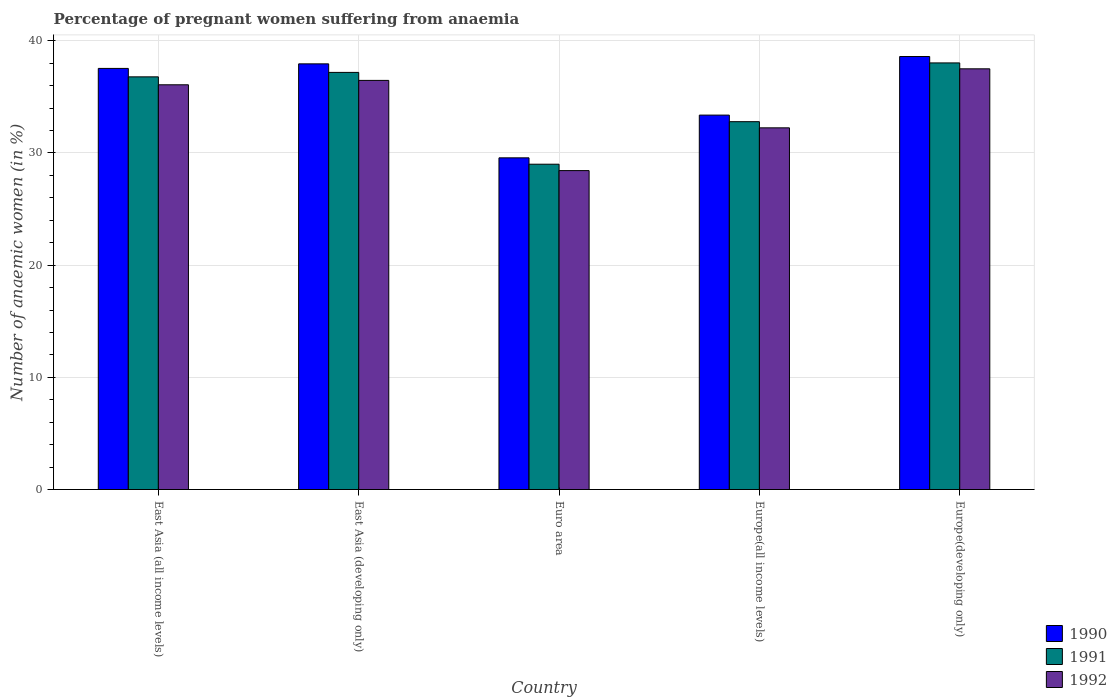Are the number of bars per tick equal to the number of legend labels?
Give a very brief answer. Yes. Are the number of bars on each tick of the X-axis equal?
Offer a terse response. Yes. What is the label of the 3rd group of bars from the left?
Keep it short and to the point. Euro area. What is the number of anaemic women in 1991 in Europe(developing only)?
Keep it short and to the point. 38.02. Across all countries, what is the maximum number of anaemic women in 1992?
Offer a very short reply. 37.5. Across all countries, what is the minimum number of anaemic women in 1992?
Give a very brief answer. 28.43. In which country was the number of anaemic women in 1992 maximum?
Your response must be concise. Europe(developing only). In which country was the number of anaemic women in 1992 minimum?
Your answer should be compact. Euro area. What is the total number of anaemic women in 1992 in the graph?
Provide a succinct answer. 170.7. What is the difference between the number of anaemic women in 1991 in East Asia (all income levels) and that in Europe(developing only)?
Your response must be concise. -1.24. What is the difference between the number of anaemic women in 1991 in Europe(developing only) and the number of anaemic women in 1992 in East Asia (developing only)?
Give a very brief answer. 1.56. What is the average number of anaemic women in 1991 per country?
Give a very brief answer. 34.75. What is the difference between the number of anaemic women of/in 1991 and number of anaemic women of/in 1990 in Europe(all income levels)?
Your response must be concise. -0.59. In how many countries, is the number of anaemic women in 1990 greater than 32 %?
Your response must be concise. 4. What is the ratio of the number of anaemic women in 1990 in Euro area to that in Europe(all income levels)?
Your answer should be compact. 0.89. What is the difference between the highest and the second highest number of anaemic women in 1990?
Provide a short and direct response. -0.41. What is the difference between the highest and the lowest number of anaemic women in 1992?
Your response must be concise. 9.07. What does the 1st bar from the left in Europe(all income levels) represents?
Keep it short and to the point. 1990. What does the 3rd bar from the right in East Asia (all income levels) represents?
Give a very brief answer. 1990. How many bars are there?
Provide a succinct answer. 15. Are all the bars in the graph horizontal?
Make the answer very short. No. What is the difference between two consecutive major ticks on the Y-axis?
Your answer should be very brief. 10. Are the values on the major ticks of Y-axis written in scientific E-notation?
Your response must be concise. No. Does the graph contain any zero values?
Your answer should be compact. No. Where does the legend appear in the graph?
Your answer should be compact. Bottom right. How many legend labels are there?
Give a very brief answer. 3. What is the title of the graph?
Make the answer very short. Percentage of pregnant women suffering from anaemia. Does "2014" appear as one of the legend labels in the graph?
Your answer should be very brief. No. What is the label or title of the Y-axis?
Your answer should be very brief. Number of anaemic women (in %). What is the Number of anaemic women (in %) in 1990 in East Asia (all income levels)?
Give a very brief answer. 37.53. What is the Number of anaemic women (in %) of 1991 in East Asia (all income levels)?
Provide a short and direct response. 36.78. What is the Number of anaemic women (in %) of 1992 in East Asia (all income levels)?
Keep it short and to the point. 36.07. What is the Number of anaemic women (in %) in 1990 in East Asia (developing only)?
Ensure brevity in your answer.  37.94. What is the Number of anaemic women (in %) in 1991 in East Asia (developing only)?
Keep it short and to the point. 37.18. What is the Number of anaemic women (in %) in 1992 in East Asia (developing only)?
Provide a succinct answer. 36.47. What is the Number of anaemic women (in %) in 1990 in Euro area?
Give a very brief answer. 29.56. What is the Number of anaemic women (in %) in 1991 in Euro area?
Provide a short and direct response. 29. What is the Number of anaemic women (in %) in 1992 in Euro area?
Make the answer very short. 28.43. What is the Number of anaemic women (in %) of 1990 in Europe(all income levels)?
Provide a succinct answer. 33.37. What is the Number of anaemic women (in %) in 1991 in Europe(all income levels)?
Your response must be concise. 32.79. What is the Number of anaemic women (in %) of 1992 in Europe(all income levels)?
Your answer should be very brief. 32.24. What is the Number of anaemic women (in %) in 1990 in Europe(developing only)?
Give a very brief answer. 38.59. What is the Number of anaemic women (in %) in 1991 in Europe(developing only)?
Provide a short and direct response. 38.02. What is the Number of anaemic women (in %) in 1992 in Europe(developing only)?
Offer a terse response. 37.5. Across all countries, what is the maximum Number of anaemic women (in %) of 1990?
Your answer should be very brief. 38.59. Across all countries, what is the maximum Number of anaemic women (in %) of 1991?
Provide a short and direct response. 38.02. Across all countries, what is the maximum Number of anaemic women (in %) of 1992?
Provide a succinct answer. 37.5. Across all countries, what is the minimum Number of anaemic women (in %) of 1990?
Provide a short and direct response. 29.56. Across all countries, what is the minimum Number of anaemic women (in %) in 1991?
Ensure brevity in your answer.  29. Across all countries, what is the minimum Number of anaemic women (in %) in 1992?
Make the answer very short. 28.43. What is the total Number of anaemic women (in %) in 1990 in the graph?
Ensure brevity in your answer.  177. What is the total Number of anaemic women (in %) of 1991 in the graph?
Provide a succinct answer. 173.77. What is the total Number of anaemic women (in %) in 1992 in the graph?
Offer a terse response. 170.7. What is the difference between the Number of anaemic women (in %) of 1990 in East Asia (all income levels) and that in East Asia (developing only)?
Ensure brevity in your answer.  -0.41. What is the difference between the Number of anaemic women (in %) of 1991 in East Asia (all income levels) and that in East Asia (developing only)?
Your answer should be compact. -0.4. What is the difference between the Number of anaemic women (in %) of 1992 in East Asia (all income levels) and that in East Asia (developing only)?
Offer a very short reply. -0.39. What is the difference between the Number of anaemic women (in %) in 1990 in East Asia (all income levels) and that in Euro area?
Provide a short and direct response. 7.97. What is the difference between the Number of anaemic women (in %) of 1991 in East Asia (all income levels) and that in Euro area?
Provide a short and direct response. 7.79. What is the difference between the Number of anaemic women (in %) in 1992 in East Asia (all income levels) and that in Euro area?
Offer a terse response. 7.65. What is the difference between the Number of anaemic women (in %) of 1990 in East Asia (all income levels) and that in Europe(all income levels)?
Make the answer very short. 4.16. What is the difference between the Number of anaemic women (in %) of 1991 in East Asia (all income levels) and that in Europe(all income levels)?
Your answer should be very brief. 4. What is the difference between the Number of anaemic women (in %) of 1992 in East Asia (all income levels) and that in Europe(all income levels)?
Your answer should be very brief. 3.84. What is the difference between the Number of anaemic women (in %) in 1990 in East Asia (all income levels) and that in Europe(developing only)?
Your answer should be very brief. -1.06. What is the difference between the Number of anaemic women (in %) in 1991 in East Asia (all income levels) and that in Europe(developing only)?
Ensure brevity in your answer.  -1.24. What is the difference between the Number of anaemic women (in %) in 1992 in East Asia (all income levels) and that in Europe(developing only)?
Your answer should be compact. -1.42. What is the difference between the Number of anaemic women (in %) in 1990 in East Asia (developing only) and that in Euro area?
Your answer should be compact. 8.38. What is the difference between the Number of anaemic women (in %) of 1991 in East Asia (developing only) and that in Euro area?
Offer a terse response. 8.18. What is the difference between the Number of anaemic women (in %) in 1992 in East Asia (developing only) and that in Euro area?
Offer a very short reply. 8.04. What is the difference between the Number of anaemic women (in %) in 1990 in East Asia (developing only) and that in Europe(all income levels)?
Provide a succinct answer. 4.57. What is the difference between the Number of anaemic women (in %) of 1991 in East Asia (developing only) and that in Europe(all income levels)?
Your response must be concise. 4.39. What is the difference between the Number of anaemic women (in %) in 1992 in East Asia (developing only) and that in Europe(all income levels)?
Offer a very short reply. 4.23. What is the difference between the Number of anaemic women (in %) in 1990 in East Asia (developing only) and that in Europe(developing only)?
Your answer should be compact. -0.65. What is the difference between the Number of anaemic women (in %) in 1991 in East Asia (developing only) and that in Europe(developing only)?
Make the answer very short. -0.85. What is the difference between the Number of anaemic women (in %) in 1992 in East Asia (developing only) and that in Europe(developing only)?
Your answer should be very brief. -1.03. What is the difference between the Number of anaemic women (in %) in 1990 in Euro area and that in Europe(all income levels)?
Make the answer very short. -3.81. What is the difference between the Number of anaemic women (in %) of 1991 in Euro area and that in Europe(all income levels)?
Provide a succinct answer. -3.79. What is the difference between the Number of anaemic women (in %) in 1992 in Euro area and that in Europe(all income levels)?
Keep it short and to the point. -3.81. What is the difference between the Number of anaemic women (in %) in 1990 in Euro area and that in Europe(developing only)?
Your answer should be compact. -9.03. What is the difference between the Number of anaemic women (in %) of 1991 in Euro area and that in Europe(developing only)?
Keep it short and to the point. -9.03. What is the difference between the Number of anaemic women (in %) in 1992 in Euro area and that in Europe(developing only)?
Provide a succinct answer. -9.07. What is the difference between the Number of anaemic women (in %) of 1990 in Europe(all income levels) and that in Europe(developing only)?
Your answer should be compact. -5.22. What is the difference between the Number of anaemic women (in %) of 1991 in Europe(all income levels) and that in Europe(developing only)?
Provide a short and direct response. -5.24. What is the difference between the Number of anaemic women (in %) in 1992 in Europe(all income levels) and that in Europe(developing only)?
Make the answer very short. -5.26. What is the difference between the Number of anaemic women (in %) of 1990 in East Asia (all income levels) and the Number of anaemic women (in %) of 1991 in East Asia (developing only)?
Offer a very short reply. 0.35. What is the difference between the Number of anaemic women (in %) of 1990 in East Asia (all income levels) and the Number of anaemic women (in %) of 1992 in East Asia (developing only)?
Offer a terse response. 1.07. What is the difference between the Number of anaemic women (in %) in 1991 in East Asia (all income levels) and the Number of anaemic women (in %) in 1992 in East Asia (developing only)?
Offer a very short reply. 0.32. What is the difference between the Number of anaemic women (in %) of 1990 in East Asia (all income levels) and the Number of anaemic women (in %) of 1991 in Euro area?
Offer a very short reply. 8.54. What is the difference between the Number of anaemic women (in %) of 1990 in East Asia (all income levels) and the Number of anaemic women (in %) of 1992 in Euro area?
Your response must be concise. 9.11. What is the difference between the Number of anaemic women (in %) of 1991 in East Asia (all income levels) and the Number of anaemic women (in %) of 1992 in Euro area?
Your answer should be compact. 8.36. What is the difference between the Number of anaemic women (in %) of 1990 in East Asia (all income levels) and the Number of anaemic women (in %) of 1991 in Europe(all income levels)?
Make the answer very short. 4.75. What is the difference between the Number of anaemic women (in %) of 1990 in East Asia (all income levels) and the Number of anaemic women (in %) of 1992 in Europe(all income levels)?
Your answer should be very brief. 5.3. What is the difference between the Number of anaemic women (in %) of 1991 in East Asia (all income levels) and the Number of anaemic women (in %) of 1992 in Europe(all income levels)?
Your answer should be very brief. 4.54. What is the difference between the Number of anaemic women (in %) of 1990 in East Asia (all income levels) and the Number of anaemic women (in %) of 1991 in Europe(developing only)?
Provide a short and direct response. -0.49. What is the difference between the Number of anaemic women (in %) in 1990 in East Asia (all income levels) and the Number of anaemic women (in %) in 1992 in Europe(developing only)?
Offer a terse response. 0.04. What is the difference between the Number of anaemic women (in %) of 1991 in East Asia (all income levels) and the Number of anaemic women (in %) of 1992 in Europe(developing only)?
Your answer should be compact. -0.72. What is the difference between the Number of anaemic women (in %) of 1990 in East Asia (developing only) and the Number of anaemic women (in %) of 1991 in Euro area?
Give a very brief answer. 8.94. What is the difference between the Number of anaemic women (in %) of 1990 in East Asia (developing only) and the Number of anaemic women (in %) of 1992 in Euro area?
Ensure brevity in your answer.  9.51. What is the difference between the Number of anaemic women (in %) of 1991 in East Asia (developing only) and the Number of anaemic women (in %) of 1992 in Euro area?
Keep it short and to the point. 8.75. What is the difference between the Number of anaemic women (in %) of 1990 in East Asia (developing only) and the Number of anaemic women (in %) of 1991 in Europe(all income levels)?
Provide a succinct answer. 5.15. What is the difference between the Number of anaemic women (in %) in 1990 in East Asia (developing only) and the Number of anaemic women (in %) in 1992 in Europe(all income levels)?
Your answer should be compact. 5.7. What is the difference between the Number of anaemic women (in %) in 1991 in East Asia (developing only) and the Number of anaemic women (in %) in 1992 in Europe(all income levels)?
Keep it short and to the point. 4.94. What is the difference between the Number of anaemic women (in %) of 1990 in East Asia (developing only) and the Number of anaemic women (in %) of 1991 in Europe(developing only)?
Keep it short and to the point. -0.08. What is the difference between the Number of anaemic women (in %) of 1990 in East Asia (developing only) and the Number of anaemic women (in %) of 1992 in Europe(developing only)?
Offer a terse response. 0.44. What is the difference between the Number of anaemic women (in %) of 1991 in East Asia (developing only) and the Number of anaemic women (in %) of 1992 in Europe(developing only)?
Provide a succinct answer. -0.32. What is the difference between the Number of anaemic women (in %) in 1990 in Euro area and the Number of anaemic women (in %) in 1991 in Europe(all income levels)?
Provide a short and direct response. -3.22. What is the difference between the Number of anaemic women (in %) in 1990 in Euro area and the Number of anaemic women (in %) in 1992 in Europe(all income levels)?
Ensure brevity in your answer.  -2.67. What is the difference between the Number of anaemic women (in %) in 1991 in Euro area and the Number of anaemic women (in %) in 1992 in Europe(all income levels)?
Make the answer very short. -3.24. What is the difference between the Number of anaemic women (in %) in 1990 in Euro area and the Number of anaemic women (in %) in 1991 in Europe(developing only)?
Offer a very short reply. -8.46. What is the difference between the Number of anaemic women (in %) in 1990 in Euro area and the Number of anaemic women (in %) in 1992 in Europe(developing only)?
Offer a very short reply. -7.93. What is the difference between the Number of anaemic women (in %) of 1991 in Euro area and the Number of anaemic women (in %) of 1992 in Europe(developing only)?
Your answer should be very brief. -8.5. What is the difference between the Number of anaemic women (in %) of 1990 in Europe(all income levels) and the Number of anaemic women (in %) of 1991 in Europe(developing only)?
Your answer should be very brief. -4.65. What is the difference between the Number of anaemic women (in %) in 1990 in Europe(all income levels) and the Number of anaemic women (in %) in 1992 in Europe(developing only)?
Ensure brevity in your answer.  -4.13. What is the difference between the Number of anaemic women (in %) in 1991 in Europe(all income levels) and the Number of anaemic women (in %) in 1992 in Europe(developing only)?
Offer a terse response. -4.71. What is the average Number of anaemic women (in %) in 1990 per country?
Provide a short and direct response. 35.4. What is the average Number of anaemic women (in %) in 1991 per country?
Keep it short and to the point. 34.75. What is the average Number of anaemic women (in %) in 1992 per country?
Ensure brevity in your answer.  34.14. What is the difference between the Number of anaemic women (in %) in 1990 and Number of anaemic women (in %) in 1991 in East Asia (all income levels)?
Provide a succinct answer. 0.75. What is the difference between the Number of anaemic women (in %) of 1990 and Number of anaemic women (in %) of 1992 in East Asia (all income levels)?
Your answer should be compact. 1.46. What is the difference between the Number of anaemic women (in %) in 1991 and Number of anaemic women (in %) in 1992 in East Asia (all income levels)?
Your response must be concise. 0.71. What is the difference between the Number of anaemic women (in %) of 1990 and Number of anaemic women (in %) of 1991 in East Asia (developing only)?
Offer a terse response. 0.76. What is the difference between the Number of anaemic women (in %) in 1990 and Number of anaemic women (in %) in 1992 in East Asia (developing only)?
Your answer should be compact. 1.47. What is the difference between the Number of anaemic women (in %) of 1991 and Number of anaemic women (in %) of 1992 in East Asia (developing only)?
Keep it short and to the point. 0.71. What is the difference between the Number of anaemic women (in %) of 1990 and Number of anaemic women (in %) of 1991 in Euro area?
Make the answer very short. 0.57. What is the difference between the Number of anaemic women (in %) of 1990 and Number of anaemic women (in %) of 1992 in Euro area?
Ensure brevity in your answer.  1.14. What is the difference between the Number of anaemic women (in %) of 1991 and Number of anaemic women (in %) of 1992 in Euro area?
Your answer should be very brief. 0.57. What is the difference between the Number of anaemic women (in %) in 1990 and Number of anaemic women (in %) in 1991 in Europe(all income levels)?
Make the answer very short. 0.59. What is the difference between the Number of anaemic women (in %) in 1990 and Number of anaemic women (in %) in 1992 in Europe(all income levels)?
Your response must be concise. 1.14. What is the difference between the Number of anaemic women (in %) in 1991 and Number of anaemic women (in %) in 1992 in Europe(all income levels)?
Offer a very short reply. 0.55. What is the difference between the Number of anaemic women (in %) in 1990 and Number of anaemic women (in %) in 1991 in Europe(developing only)?
Your answer should be compact. 0.57. What is the difference between the Number of anaemic women (in %) of 1990 and Number of anaemic women (in %) of 1992 in Europe(developing only)?
Ensure brevity in your answer.  1.1. What is the difference between the Number of anaemic women (in %) of 1991 and Number of anaemic women (in %) of 1992 in Europe(developing only)?
Your response must be concise. 0.53. What is the ratio of the Number of anaemic women (in %) of 1990 in East Asia (all income levels) to that in East Asia (developing only)?
Offer a very short reply. 0.99. What is the ratio of the Number of anaemic women (in %) of 1991 in East Asia (all income levels) to that in East Asia (developing only)?
Your answer should be very brief. 0.99. What is the ratio of the Number of anaemic women (in %) in 1992 in East Asia (all income levels) to that in East Asia (developing only)?
Provide a succinct answer. 0.99. What is the ratio of the Number of anaemic women (in %) in 1990 in East Asia (all income levels) to that in Euro area?
Give a very brief answer. 1.27. What is the ratio of the Number of anaemic women (in %) of 1991 in East Asia (all income levels) to that in Euro area?
Provide a short and direct response. 1.27. What is the ratio of the Number of anaemic women (in %) of 1992 in East Asia (all income levels) to that in Euro area?
Offer a very short reply. 1.27. What is the ratio of the Number of anaemic women (in %) of 1990 in East Asia (all income levels) to that in Europe(all income levels)?
Ensure brevity in your answer.  1.12. What is the ratio of the Number of anaemic women (in %) of 1991 in East Asia (all income levels) to that in Europe(all income levels)?
Give a very brief answer. 1.12. What is the ratio of the Number of anaemic women (in %) of 1992 in East Asia (all income levels) to that in Europe(all income levels)?
Offer a very short reply. 1.12. What is the ratio of the Number of anaemic women (in %) in 1990 in East Asia (all income levels) to that in Europe(developing only)?
Give a very brief answer. 0.97. What is the ratio of the Number of anaemic women (in %) of 1991 in East Asia (all income levels) to that in Europe(developing only)?
Offer a terse response. 0.97. What is the ratio of the Number of anaemic women (in %) of 1992 in East Asia (all income levels) to that in Europe(developing only)?
Provide a succinct answer. 0.96. What is the ratio of the Number of anaemic women (in %) in 1990 in East Asia (developing only) to that in Euro area?
Your answer should be very brief. 1.28. What is the ratio of the Number of anaemic women (in %) of 1991 in East Asia (developing only) to that in Euro area?
Your answer should be compact. 1.28. What is the ratio of the Number of anaemic women (in %) of 1992 in East Asia (developing only) to that in Euro area?
Your answer should be compact. 1.28. What is the ratio of the Number of anaemic women (in %) in 1990 in East Asia (developing only) to that in Europe(all income levels)?
Provide a short and direct response. 1.14. What is the ratio of the Number of anaemic women (in %) in 1991 in East Asia (developing only) to that in Europe(all income levels)?
Provide a succinct answer. 1.13. What is the ratio of the Number of anaemic women (in %) of 1992 in East Asia (developing only) to that in Europe(all income levels)?
Provide a short and direct response. 1.13. What is the ratio of the Number of anaemic women (in %) in 1990 in East Asia (developing only) to that in Europe(developing only)?
Give a very brief answer. 0.98. What is the ratio of the Number of anaemic women (in %) in 1991 in East Asia (developing only) to that in Europe(developing only)?
Offer a terse response. 0.98. What is the ratio of the Number of anaemic women (in %) in 1992 in East Asia (developing only) to that in Europe(developing only)?
Make the answer very short. 0.97. What is the ratio of the Number of anaemic women (in %) of 1990 in Euro area to that in Europe(all income levels)?
Provide a succinct answer. 0.89. What is the ratio of the Number of anaemic women (in %) in 1991 in Euro area to that in Europe(all income levels)?
Your answer should be compact. 0.88. What is the ratio of the Number of anaemic women (in %) in 1992 in Euro area to that in Europe(all income levels)?
Your answer should be very brief. 0.88. What is the ratio of the Number of anaemic women (in %) in 1990 in Euro area to that in Europe(developing only)?
Your answer should be very brief. 0.77. What is the ratio of the Number of anaemic women (in %) in 1991 in Euro area to that in Europe(developing only)?
Ensure brevity in your answer.  0.76. What is the ratio of the Number of anaemic women (in %) of 1992 in Euro area to that in Europe(developing only)?
Offer a terse response. 0.76. What is the ratio of the Number of anaemic women (in %) in 1990 in Europe(all income levels) to that in Europe(developing only)?
Keep it short and to the point. 0.86. What is the ratio of the Number of anaemic women (in %) in 1991 in Europe(all income levels) to that in Europe(developing only)?
Provide a succinct answer. 0.86. What is the ratio of the Number of anaemic women (in %) in 1992 in Europe(all income levels) to that in Europe(developing only)?
Your answer should be compact. 0.86. What is the difference between the highest and the second highest Number of anaemic women (in %) of 1990?
Offer a very short reply. 0.65. What is the difference between the highest and the second highest Number of anaemic women (in %) in 1991?
Provide a short and direct response. 0.85. What is the difference between the highest and the second highest Number of anaemic women (in %) of 1992?
Make the answer very short. 1.03. What is the difference between the highest and the lowest Number of anaemic women (in %) in 1990?
Provide a short and direct response. 9.03. What is the difference between the highest and the lowest Number of anaemic women (in %) in 1991?
Offer a terse response. 9.03. What is the difference between the highest and the lowest Number of anaemic women (in %) of 1992?
Make the answer very short. 9.07. 